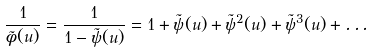<formula> <loc_0><loc_0><loc_500><loc_500>\frac { 1 } { \tilde { \phi } ( u ) } = \frac { 1 } { 1 - \tilde { \psi } ( u ) } = 1 + \tilde { \psi } ( u ) + \tilde { \psi } ^ { 2 } ( u ) + \tilde { \psi } ^ { 3 } ( u ) + \dots</formula> 